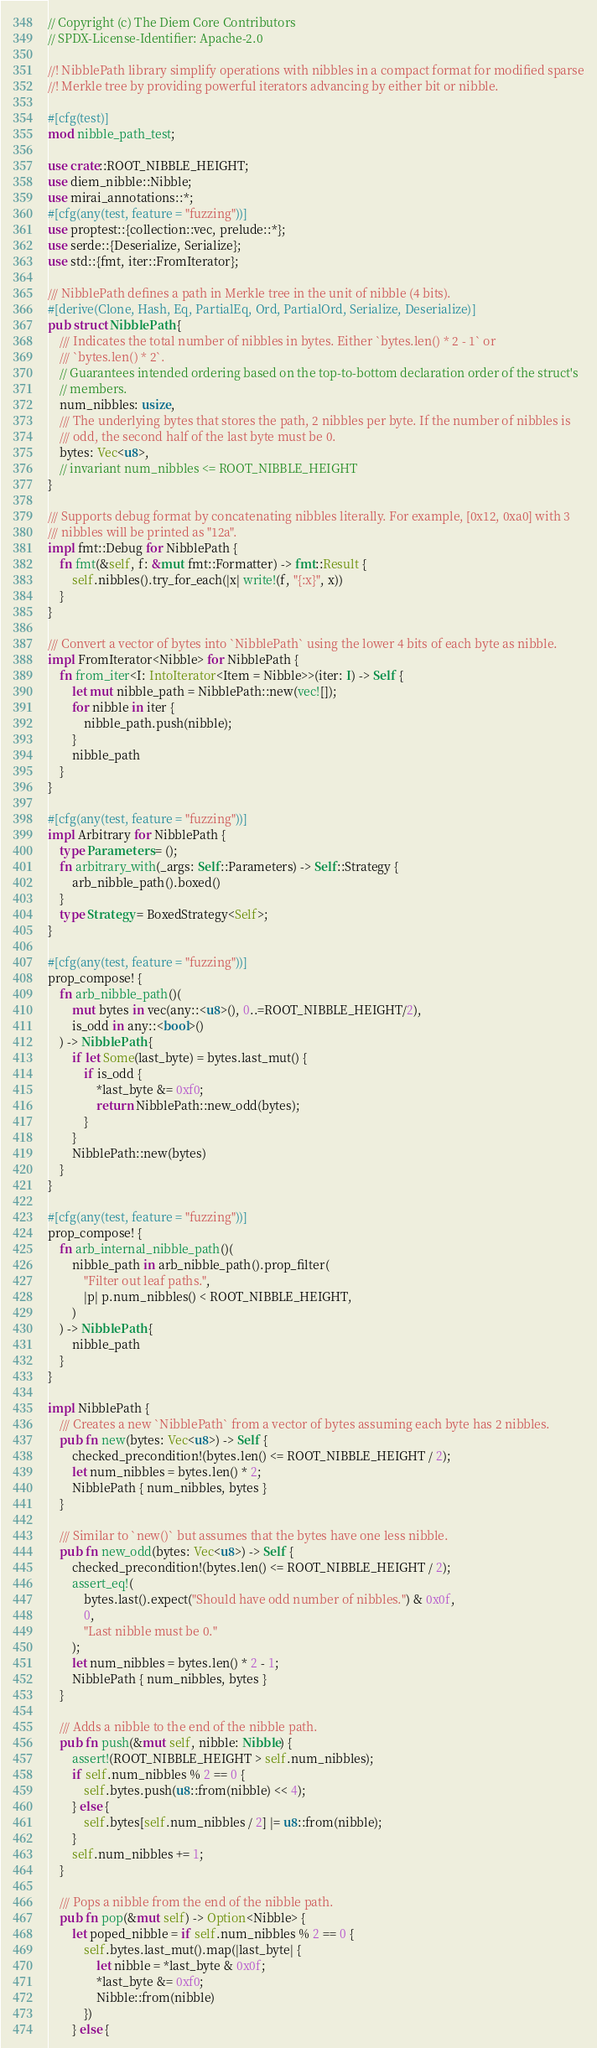Convert code to text. <code><loc_0><loc_0><loc_500><loc_500><_Rust_>// Copyright (c) The Diem Core Contributors
// SPDX-License-Identifier: Apache-2.0

//! NibblePath library simplify operations with nibbles in a compact format for modified sparse
//! Merkle tree by providing powerful iterators advancing by either bit or nibble.

#[cfg(test)]
mod nibble_path_test;

use crate::ROOT_NIBBLE_HEIGHT;
use diem_nibble::Nibble;
use mirai_annotations::*;
#[cfg(any(test, feature = "fuzzing"))]
use proptest::{collection::vec, prelude::*};
use serde::{Deserialize, Serialize};
use std::{fmt, iter::FromIterator};

/// NibblePath defines a path in Merkle tree in the unit of nibble (4 bits).
#[derive(Clone, Hash, Eq, PartialEq, Ord, PartialOrd, Serialize, Deserialize)]
pub struct NibblePath {
    /// Indicates the total number of nibbles in bytes. Either `bytes.len() * 2 - 1` or
    /// `bytes.len() * 2`.
    // Guarantees intended ordering based on the top-to-bottom declaration order of the struct's
    // members.
    num_nibbles: usize,
    /// The underlying bytes that stores the path, 2 nibbles per byte. If the number of nibbles is
    /// odd, the second half of the last byte must be 0.
    bytes: Vec<u8>,
    // invariant num_nibbles <= ROOT_NIBBLE_HEIGHT
}

/// Supports debug format by concatenating nibbles literally. For example, [0x12, 0xa0] with 3
/// nibbles will be printed as "12a".
impl fmt::Debug for NibblePath {
    fn fmt(&self, f: &mut fmt::Formatter) -> fmt::Result {
        self.nibbles().try_for_each(|x| write!(f, "{:x}", x))
    }
}

/// Convert a vector of bytes into `NibblePath` using the lower 4 bits of each byte as nibble.
impl FromIterator<Nibble> for NibblePath {
    fn from_iter<I: IntoIterator<Item = Nibble>>(iter: I) -> Self {
        let mut nibble_path = NibblePath::new(vec![]);
        for nibble in iter {
            nibble_path.push(nibble);
        }
        nibble_path
    }
}

#[cfg(any(test, feature = "fuzzing"))]
impl Arbitrary for NibblePath {
    type Parameters = ();
    fn arbitrary_with(_args: Self::Parameters) -> Self::Strategy {
        arb_nibble_path().boxed()
    }
    type Strategy = BoxedStrategy<Self>;
}

#[cfg(any(test, feature = "fuzzing"))]
prop_compose! {
    fn arb_nibble_path()(
        mut bytes in vec(any::<u8>(), 0..=ROOT_NIBBLE_HEIGHT/2),
        is_odd in any::<bool>()
    ) -> NibblePath {
        if let Some(last_byte) = bytes.last_mut() {
            if is_odd {
                *last_byte &= 0xf0;
                return NibblePath::new_odd(bytes);
            }
        }
        NibblePath::new(bytes)
    }
}

#[cfg(any(test, feature = "fuzzing"))]
prop_compose! {
    fn arb_internal_nibble_path()(
        nibble_path in arb_nibble_path().prop_filter(
            "Filter out leaf paths.",
            |p| p.num_nibbles() < ROOT_NIBBLE_HEIGHT,
        )
    ) -> NibblePath {
        nibble_path
    }
}

impl NibblePath {
    /// Creates a new `NibblePath` from a vector of bytes assuming each byte has 2 nibbles.
    pub fn new(bytes: Vec<u8>) -> Self {
        checked_precondition!(bytes.len() <= ROOT_NIBBLE_HEIGHT / 2);
        let num_nibbles = bytes.len() * 2;
        NibblePath { num_nibbles, bytes }
    }

    /// Similar to `new()` but assumes that the bytes have one less nibble.
    pub fn new_odd(bytes: Vec<u8>) -> Self {
        checked_precondition!(bytes.len() <= ROOT_NIBBLE_HEIGHT / 2);
        assert_eq!(
            bytes.last().expect("Should have odd number of nibbles.") & 0x0f,
            0,
            "Last nibble must be 0."
        );
        let num_nibbles = bytes.len() * 2 - 1;
        NibblePath { num_nibbles, bytes }
    }

    /// Adds a nibble to the end of the nibble path.
    pub fn push(&mut self, nibble: Nibble) {
        assert!(ROOT_NIBBLE_HEIGHT > self.num_nibbles);
        if self.num_nibbles % 2 == 0 {
            self.bytes.push(u8::from(nibble) << 4);
        } else {
            self.bytes[self.num_nibbles / 2] |= u8::from(nibble);
        }
        self.num_nibbles += 1;
    }

    /// Pops a nibble from the end of the nibble path.
    pub fn pop(&mut self) -> Option<Nibble> {
        let poped_nibble = if self.num_nibbles % 2 == 0 {
            self.bytes.last_mut().map(|last_byte| {
                let nibble = *last_byte & 0x0f;
                *last_byte &= 0xf0;
                Nibble::from(nibble)
            })
        } else {</code> 